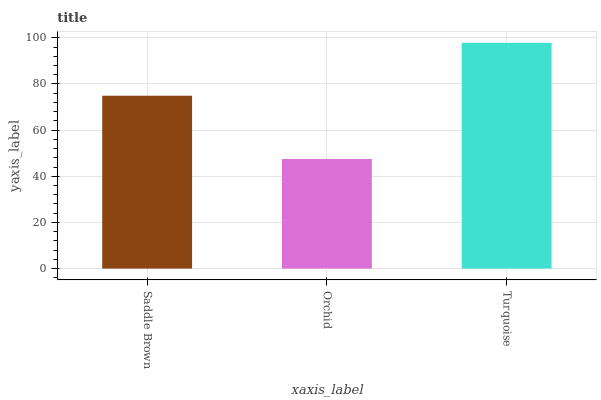Is Orchid the minimum?
Answer yes or no. Yes. Is Turquoise the maximum?
Answer yes or no. Yes. Is Turquoise the minimum?
Answer yes or no. No. Is Orchid the maximum?
Answer yes or no. No. Is Turquoise greater than Orchid?
Answer yes or no. Yes. Is Orchid less than Turquoise?
Answer yes or no. Yes. Is Orchid greater than Turquoise?
Answer yes or no. No. Is Turquoise less than Orchid?
Answer yes or no. No. Is Saddle Brown the high median?
Answer yes or no. Yes. Is Saddle Brown the low median?
Answer yes or no. Yes. Is Orchid the high median?
Answer yes or no. No. Is Orchid the low median?
Answer yes or no. No. 